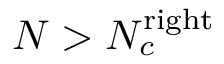<formula> <loc_0><loc_0><loc_500><loc_500>N > N _ { c } ^ { r i g h t }</formula> 